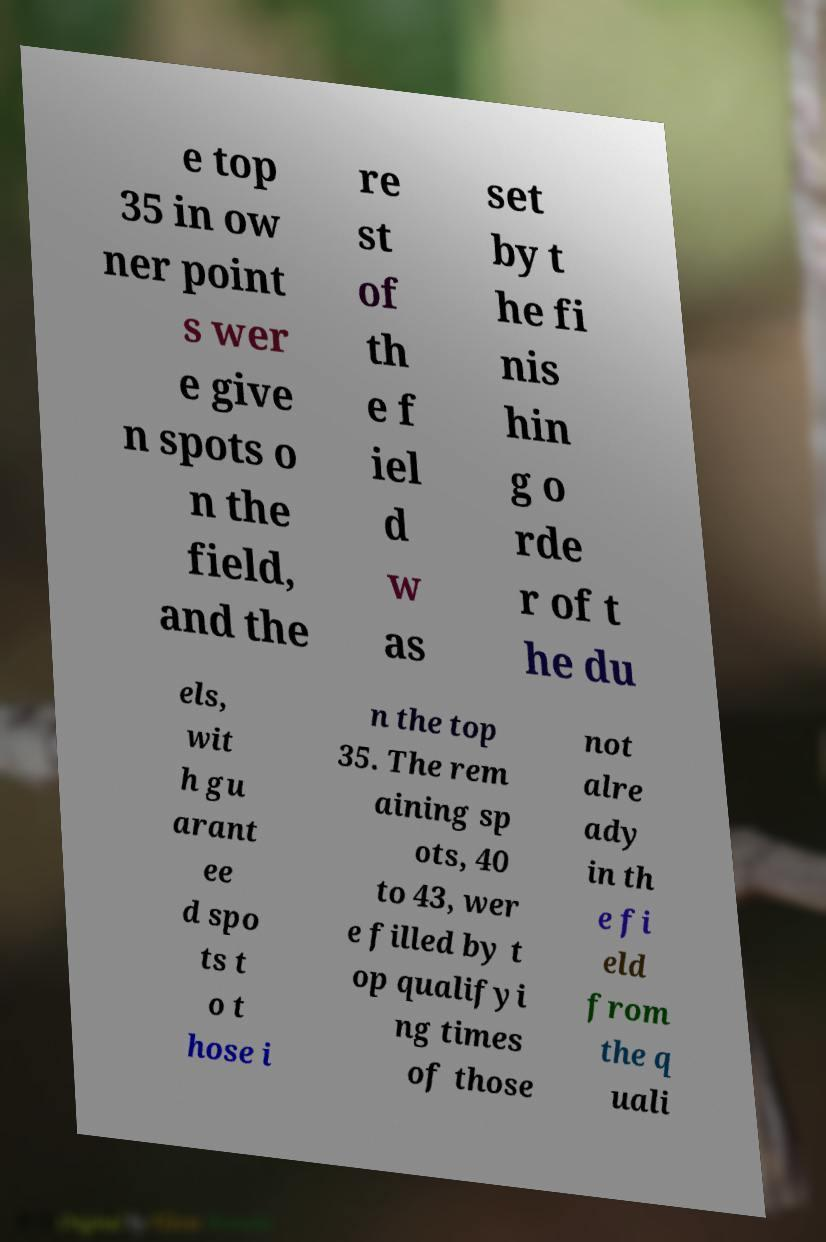For documentation purposes, I need the text within this image transcribed. Could you provide that? e top 35 in ow ner point s wer e give n spots o n the field, and the re st of th e f iel d w as set by t he fi nis hin g o rde r of t he du els, wit h gu arant ee d spo ts t o t hose i n the top 35. The rem aining sp ots, 40 to 43, wer e filled by t op qualifyi ng times of those not alre ady in th e fi eld from the q uali 